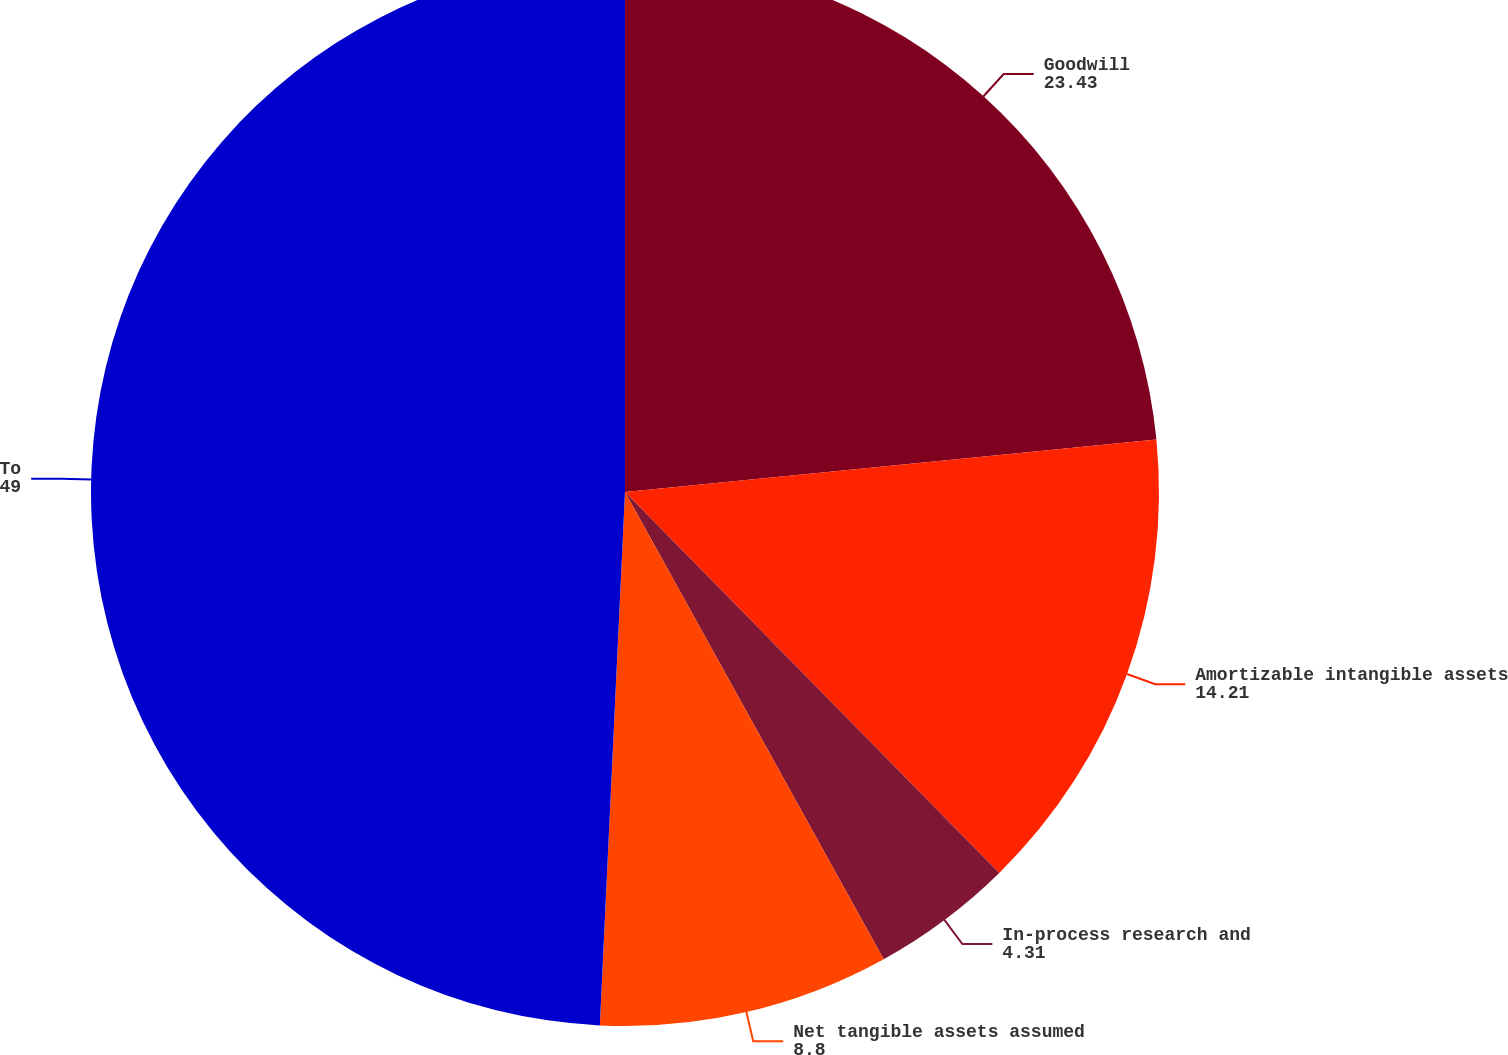Convert chart. <chart><loc_0><loc_0><loc_500><loc_500><pie_chart><fcel>Goodwill<fcel>Amortizable intangible assets<fcel>In-process research and<fcel>Net tangible assets assumed<fcel>Total fair value consideration<nl><fcel>23.43%<fcel>14.21%<fcel>4.31%<fcel>8.8%<fcel>49.25%<nl></chart> 